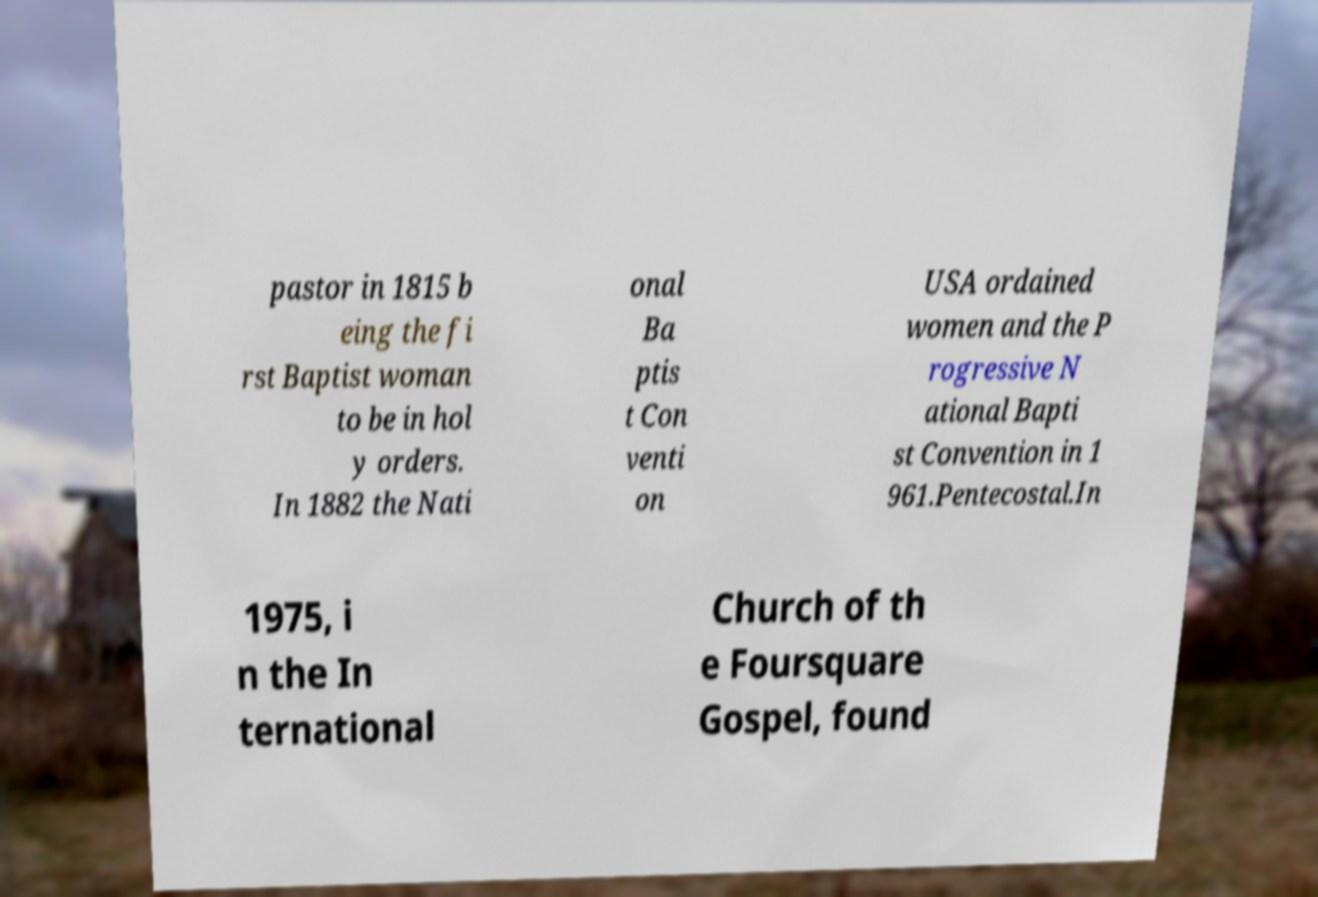There's text embedded in this image that I need extracted. Can you transcribe it verbatim? pastor in 1815 b eing the fi rst Baptist woman to be in hol y orders. In 1882 the Nati onal Ba ptis t Con venti on USA ordained women and the P rogressive N ational Bapti st Convention in 1 961.Pentecostal.In 1975, i n the In ternational Church of th e Foursquare Gospel, found 